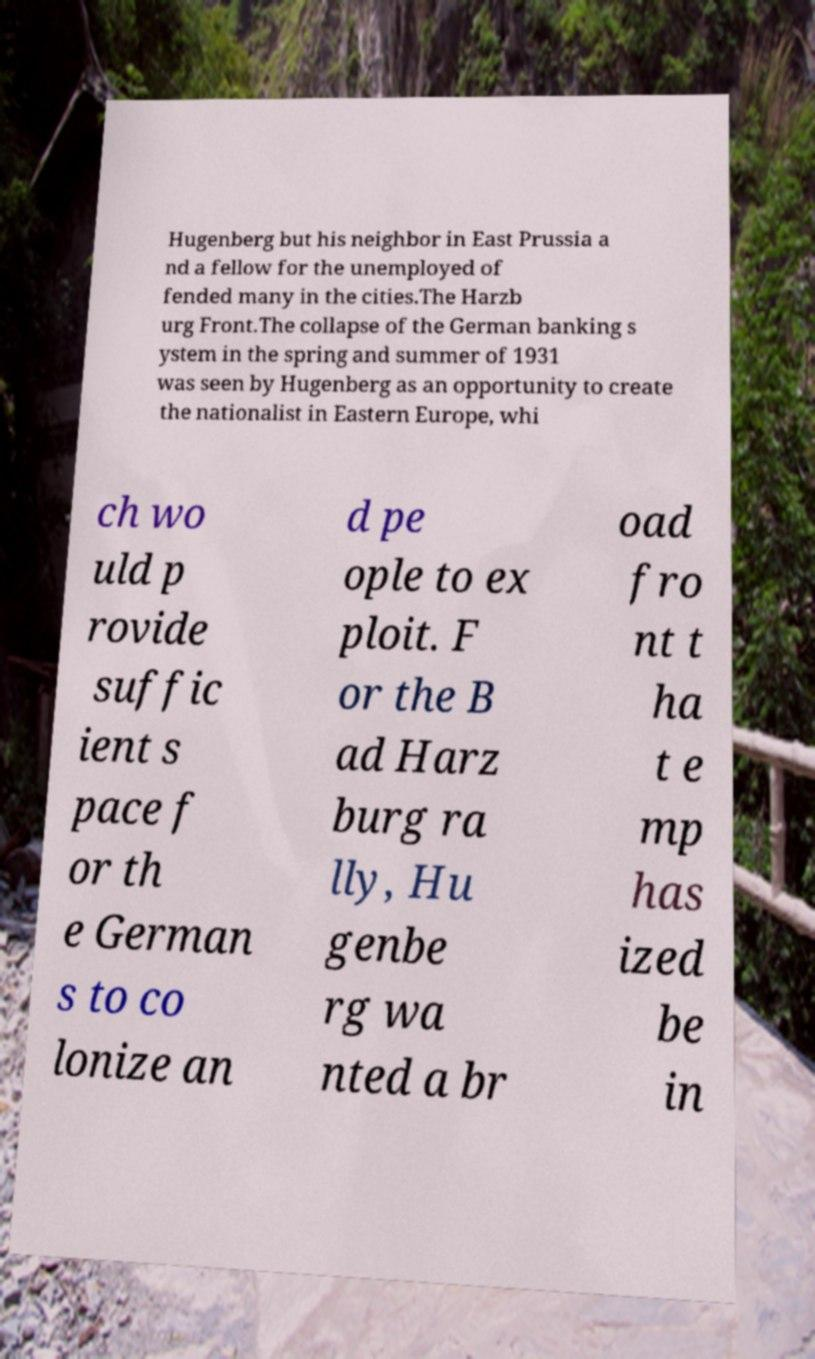What messages or text are displayed in this image? I need them in a readable, typed format. Hugenberg but his neighbor in East Prussia a nd a fellow for the unemployed of fended many in the cities.The Harzb urg Front.The collapse of the German banking s ystem in the spring and summer of 1931 was seen by Hugenberg as an opportunity to create the nationalist in Eastern Europe, whi ch wo uld p rovide suffic ient s pace f or th e German s to co lonize an d pe ople to ex ploit. F or the B ad Harz burg ra lly, Hu genbe rg wa nted a br oad fro nt t ha t e mp has ized be in 